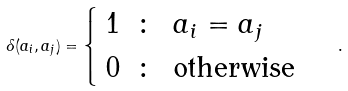<formula> <loc_0><loc_0><loc_500><loc_500>\delta ( a _ { i } , a _ { j } ) = \begin{cases} \begin{array} { l l l } 1 & \colon & a _ { i } = a _ { j } \\ 0 & \colon & \text {otherwise} \end{array} \end{cases} .</formula> 